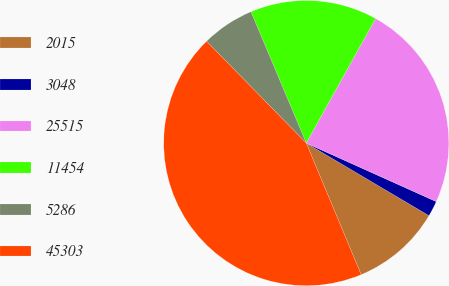Convert chart to OTSL. <chart><loc_0><loc_0><loc_500><loc_500><pie_chart><fcel>2015<fcel>3048<fcel>25515<fcel>11454<fcel>5286<fcel>45303<nl><fcel>10.21%<fcel>1.77%<fcel>23.65%<fcel>14.43%<fcel>5.99%<fcel>43.97%<nl></chart> 